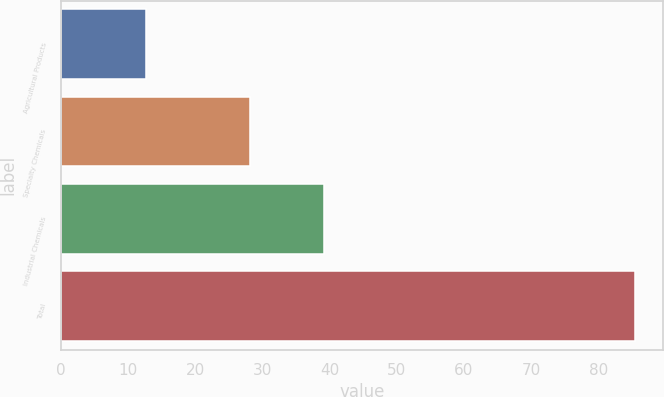Convert chart to OTSL. <chart><loc_0><loc_0><loc_500><loc_500><bar_chart><fcel>Agricultural Products<fcel>Specialty Chemicals<fcel>Industrial Chemicals<fcel>Total<nl><fcel>12.6<fcel>28.2<fcel>39.2<fcel>85.4<nl></chart> 